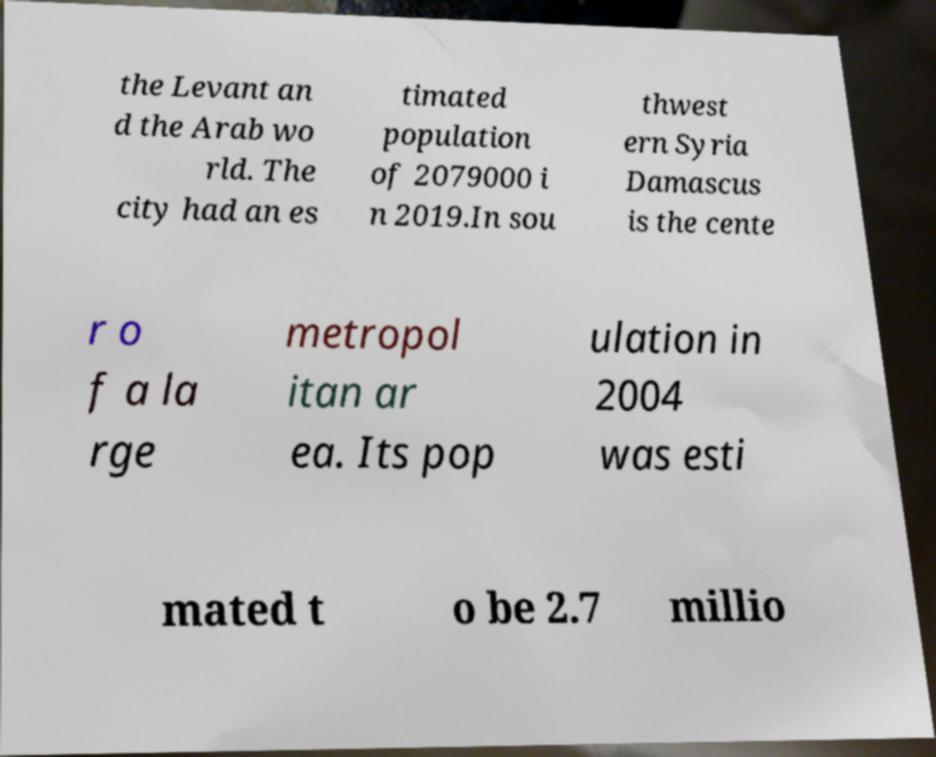Can you read and provide the text displayed in the image?This photo seems to have some interesting text. Can you extract and type it out for me? the Levant an d the Arab wo rld. The city had an es timated population of 2079000 i n 2019.In sou thwest ern Syria Damascus is the cente r o f a la rge metropol itan ar ea. Its pop ulation in 2004 was esti mated t o be 2.7 millio 